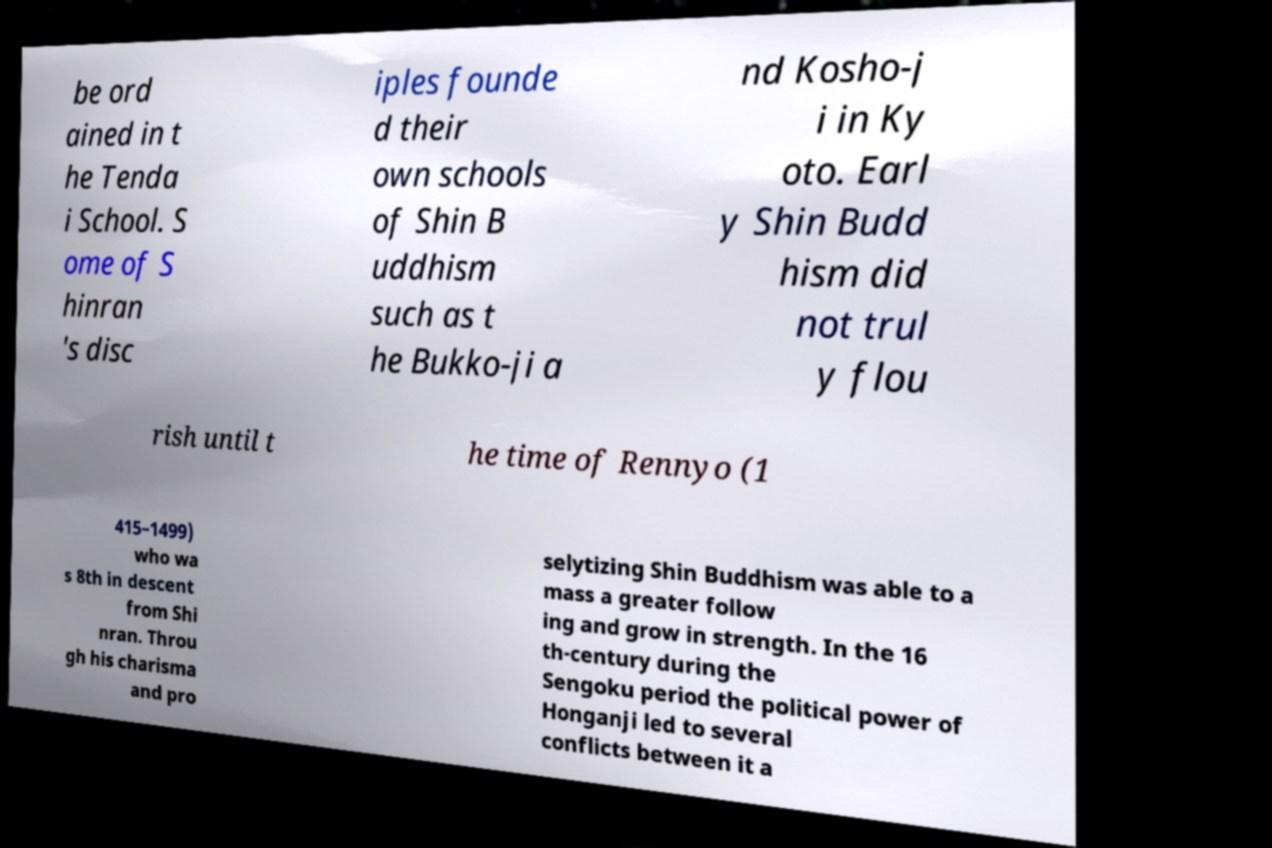Please read and relay the text visible in this image. What does it say? be ord ained in t he Tenda i School. S ome of S hinran 's disc iples founde d their own schools of Shin B uddhism such as t he Bukko-ji a nd Kosho-j i in Ky oto. Earl y Shin Budd hism did not trul y flou rish until t he time of Rennyo (1 415–1499) who wa s 8th in descent from Shi nran. Throu gh his charisma and pro selytizing Shin Buddhism was able to a mass a greater follow ing and grow in strength. In the 16 th-century during the Sengoku period the political power of Honganji led to several conflicts between it a 